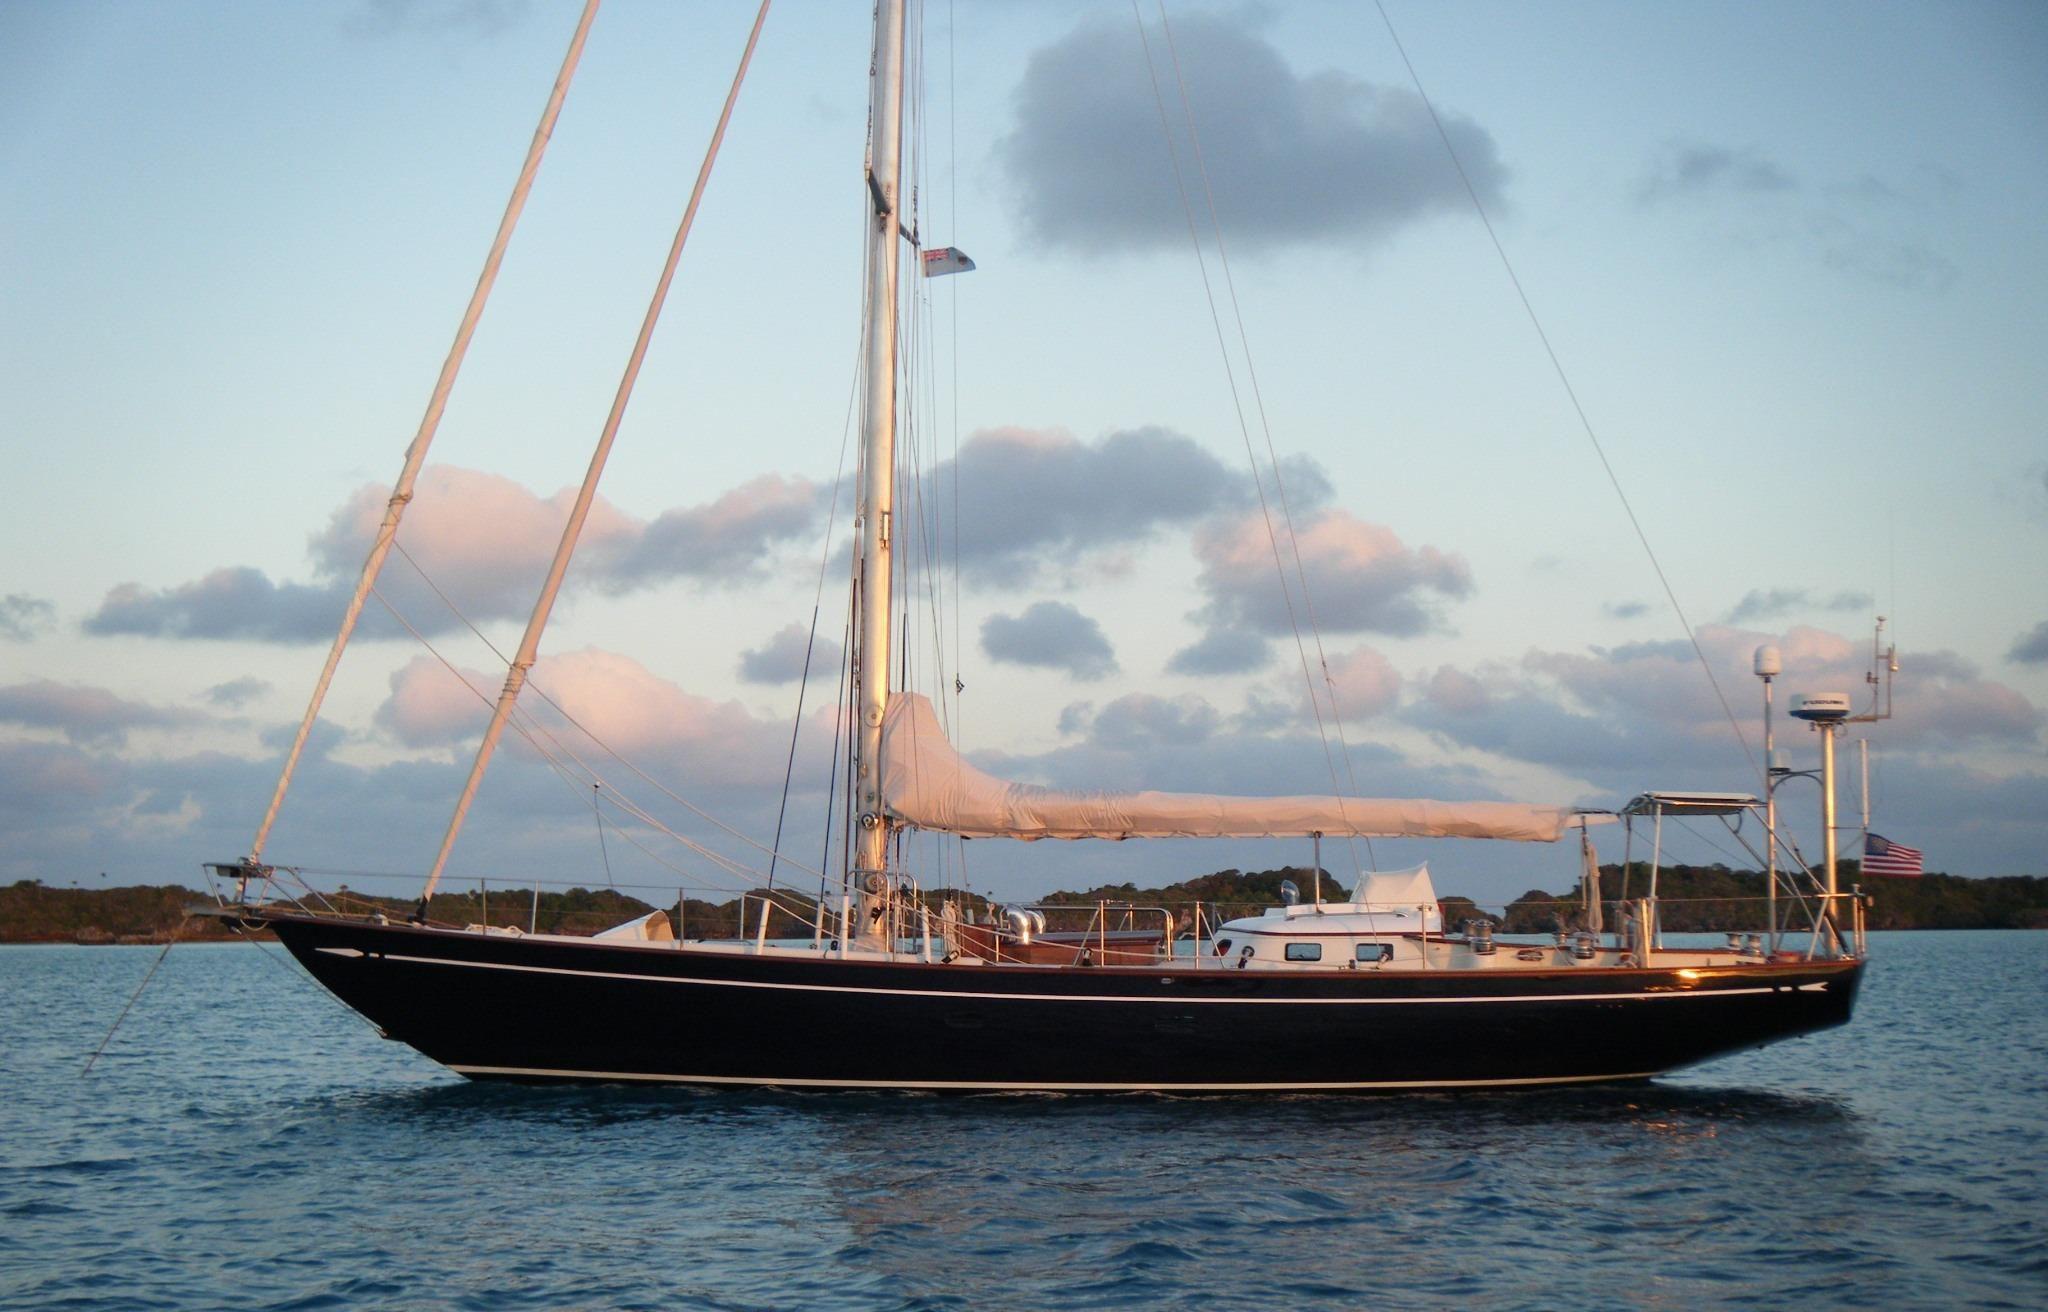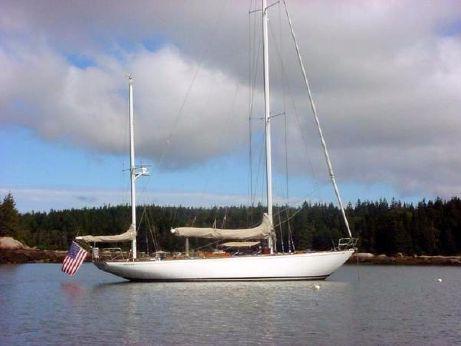The first image is the image on the left, the second image is the image on the right. Evaluate the accuracy of this statement regarding the images: "At least one white sail is up.". Is it true? Answer yes or no. No. The first image is the image on the left, the second image is the image on the right. Evaluate the accuracy of this statement regarding the images: "A second boat is visible behind the closer boat in the image on the left.". Is it true? Answer yes or no. No. 